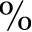<formula> <loc_0><loc_0><loc_500><loc_500>\%</formula> 